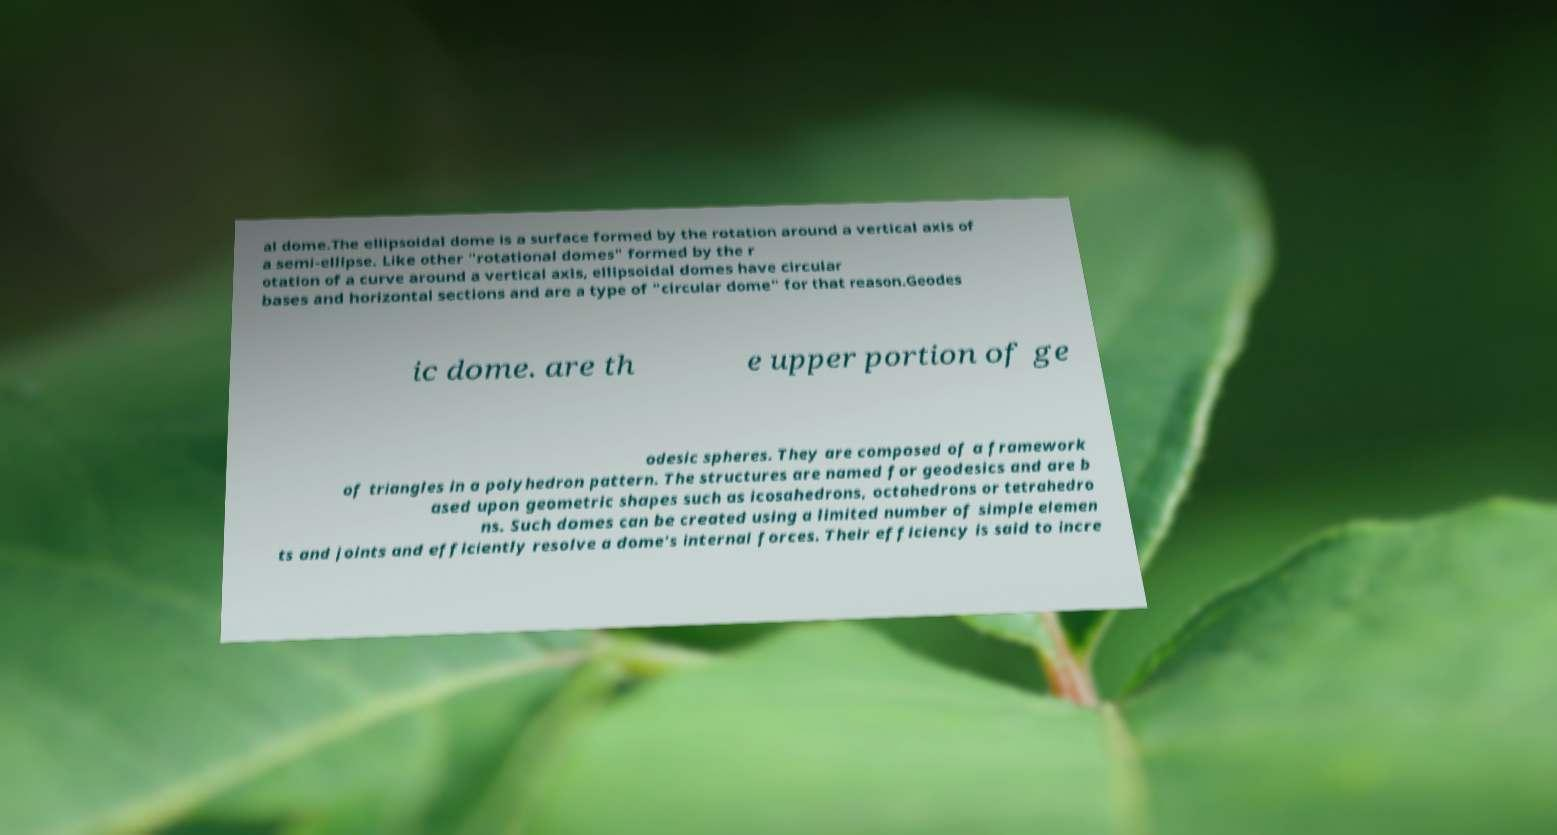I need the written content from this picture converted into text. Can you do that? al dome.The ellipsoidal dome is a surface formed by the rotation around a vertical axis of a semi-ellipse. Like other "rotational domes" formed by the r otation of a curve around a vertical axis, ellipsoidal domes have circular bases and horizontal sections and are a type of "circular dome" for that reason.Geodes ic dome. are th e upper portion of ge odesic spheres. They are composed of a framework of triangles in a polyhedron pattern. The structures are named for geodesics and are b ased upon geometric shapes such as icosahedrons, octahedrons or tetrahedro ns. Such domes can be created using a limited number of simple elemen ts and joints and efficiently resolve a dome's internal forces. Their efficiency is said to incre 